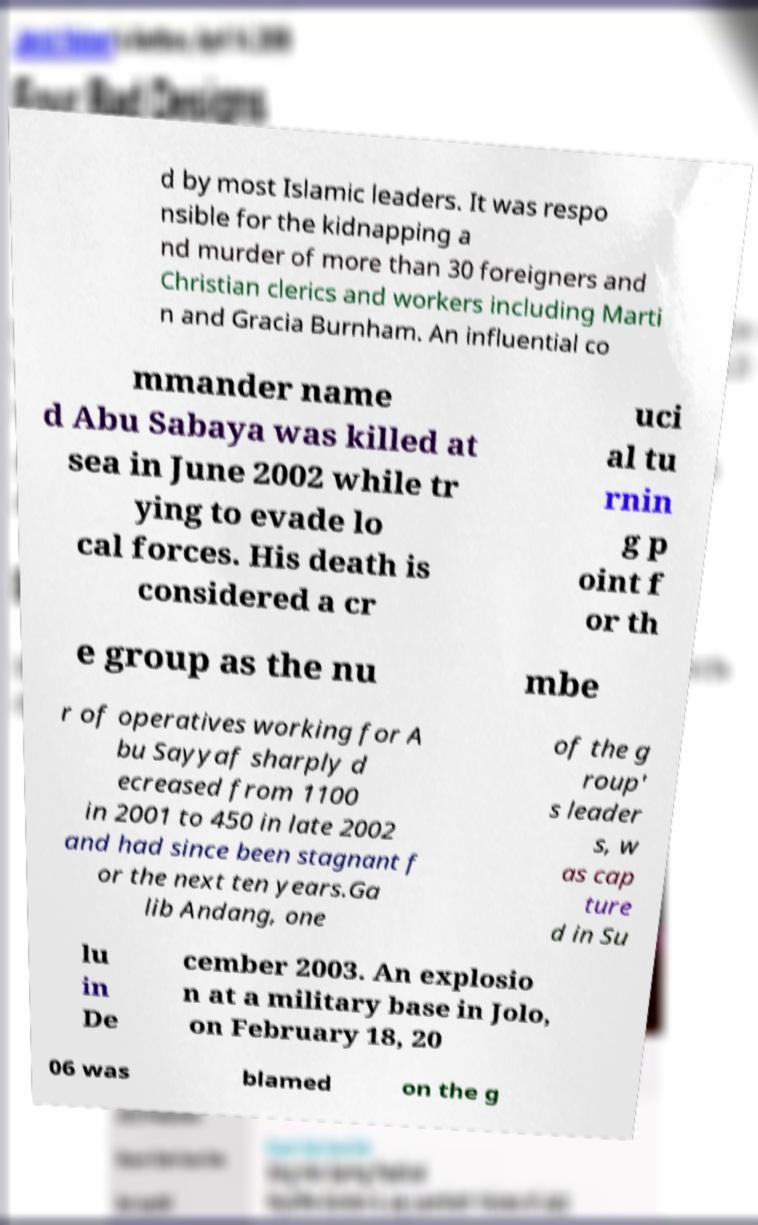Could you assist in decoding the text presented in this image and type it out clearly? d by most Islamic leaders. It was respo nsible for the kidnapping a nd murder of more than 30 foreigners and Christian clerics and workers including Marti n and Gracia Burnham. An influential co mmander name d Abu Sabaya was killed at sea in June 2002 while tr ying to evade lo cal forces. His death is considered a cr uci al tu rnin g p oint f or th e group as the nu mbe r of operatives working for A bu Sayyaf sharply d ecreased from 1100 in 2001 to 450 in late 2002 and had since been stagnant f or the next ten years.Ga lib Andang, one of the g roup' s leader s, w as cap ture d in Su lu in De cember 2003. An explosio n at a military base in Jolo, on February 18, 20 06 was blamed on the g 